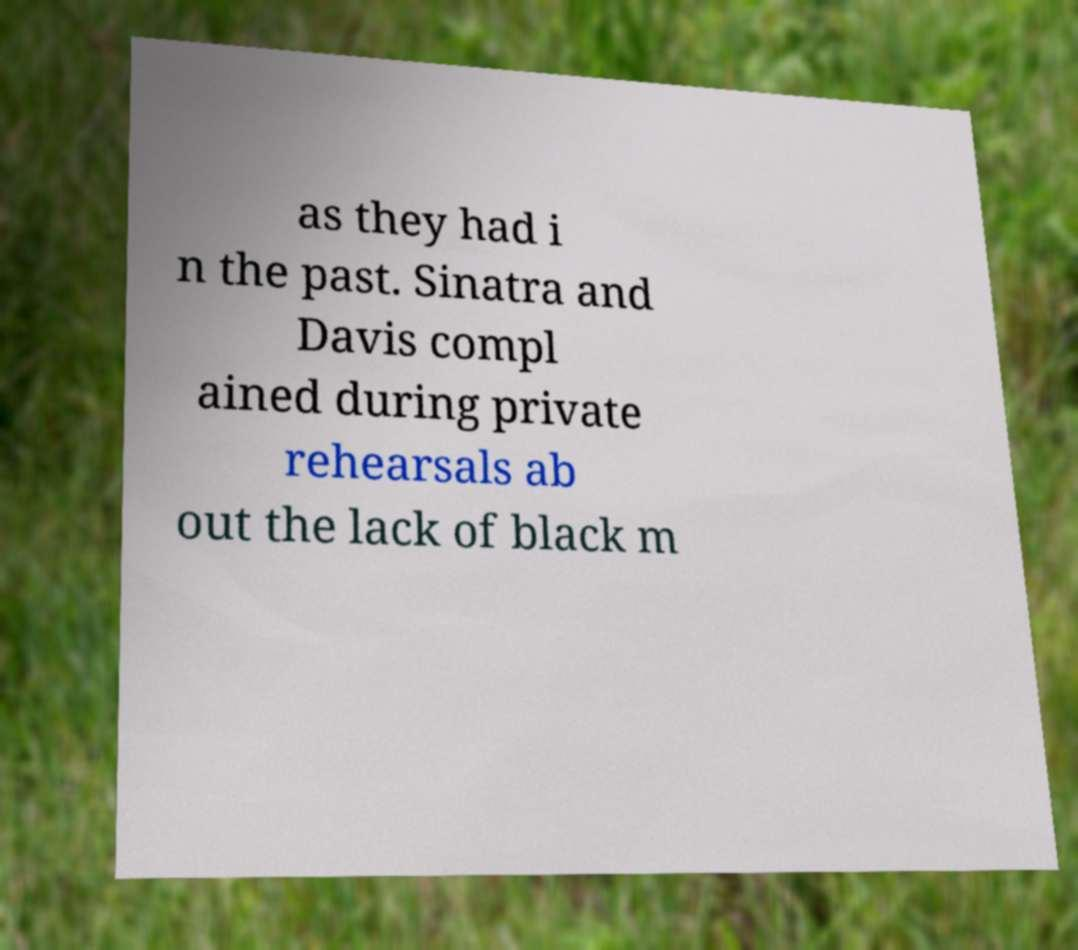Could you assist in decoding the text presented in this image and type it out clearly? as they had i n the past. Sinatra and Davis compl ained during private rehearsals ab out the lack of black m 